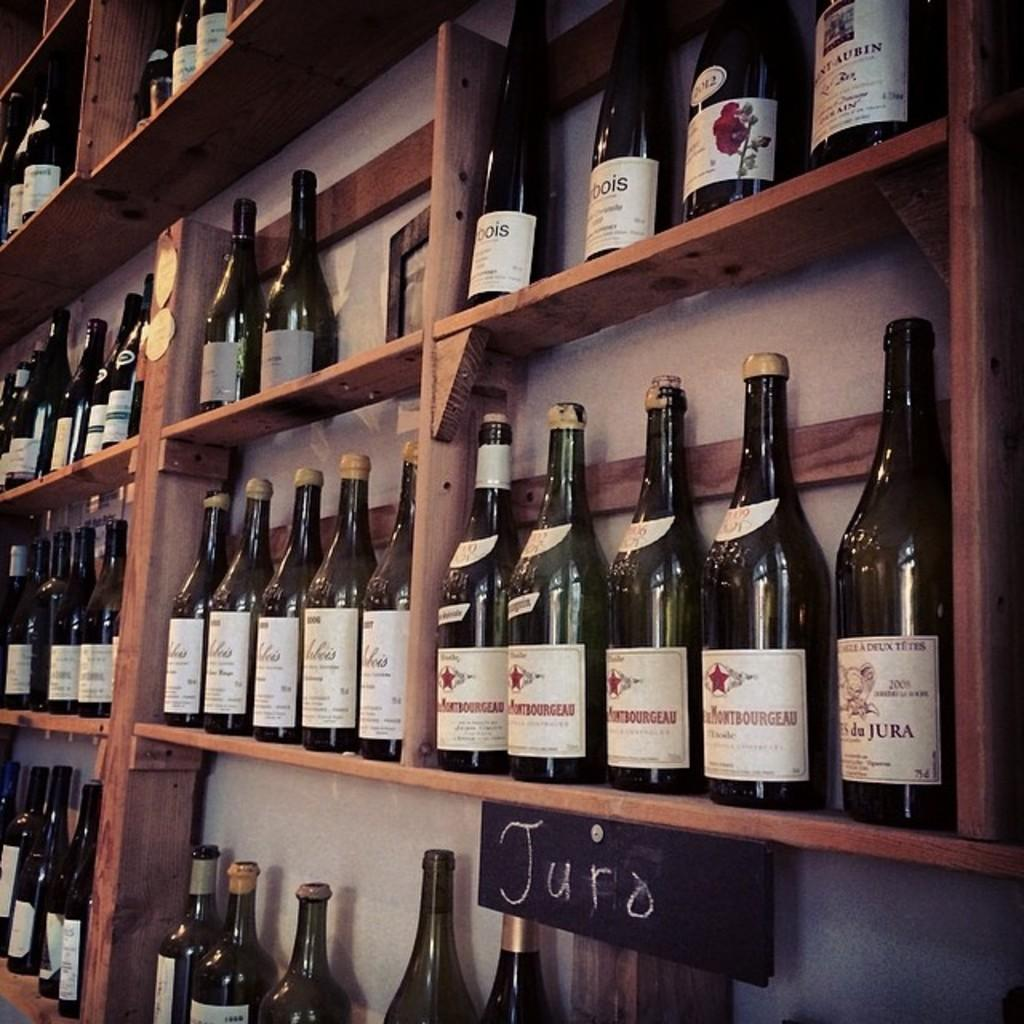<image>
Render a clear and concise summary of the photo. wines are sitting on wooden shelves and one shelf is labeled Juro 